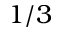<formula> <loc_0><loc_0><loc_500><loc_500>1 / 3</formula> 